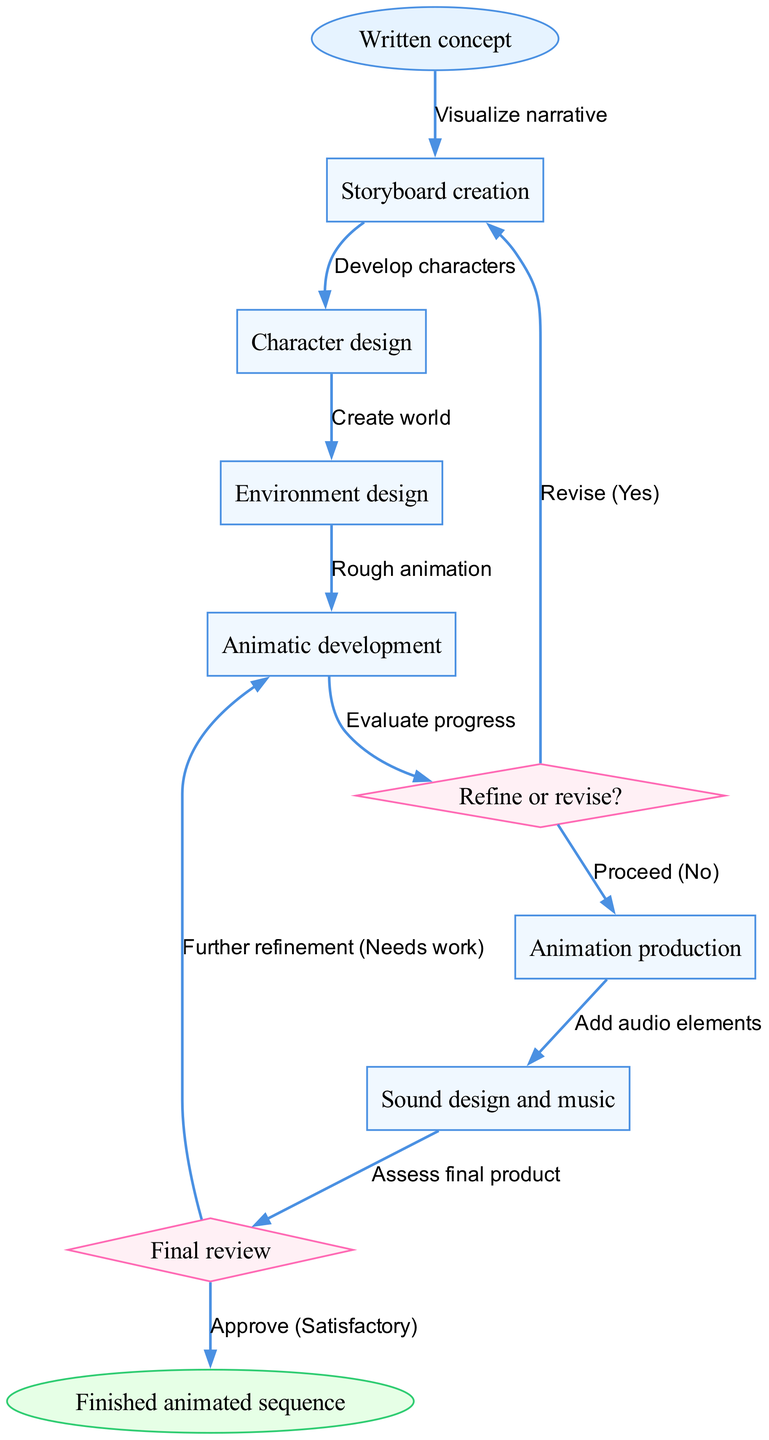What is the starting point of the process? The starting point of the process is identified as the "Written concept," which is the first element in the diagram.
Answer: Written concept How many decision points are there in the flow chart? There are two decision points in the flow chart, indicated by diamond-shaped nodes representing choices or evaluations.
Answer: 2 Which step follows "Animatic development"? According to the flow chart, the step that follows "Animatic development" is the "Refine or revise?" decision point. This indicates that after creating the animatic, a decision must be made regarding whether to proceed with production or revise the earlier steps.
Answer: Refine or revise? What action is taken if the final review indicates the product "Needs work"? If the final review indicates that the product "Needs work," the flow directs the process back to "Animatic development" for further refinement.
Answer: Further refinement What is the last node in the flow chart? The last node in the flow chart is "Finished animated sequence," which represents the end of the creative process.
Answer: Finished animated sequence How do you proceed if the "Refine or revise?" decision is answered with "No"? If the "Refine or revise?" decision is answered with "No," the flow chart indicates that the next step is to proceed to "Animation production." This signifies that the initial concepts were satisfactory enough to continue with production.
Answer: Animation production What is the outcome if the final review is "Satisfactory"? If the final review is determined to be "Satisfactory," the flow chart routes to the final node, which is "Finished animated sequence," signifying that the animated work meets the required standards.
Answer: Approve What is the relationship between "Environment design" and "Animatic development"? The relationship between "Environment design" and "Animatic development" is sequential, where "Environment design" must be completed before reaching "Animatic development," indicating that the environment is integrated into the animatic.
Answer: Create world Which process directly precedes "Sound design and music"? The process that directly precedes "Sound design and music" is "Animation production," highlighting that animations need to be completed before adding audio elements.
Answer: Animation production 